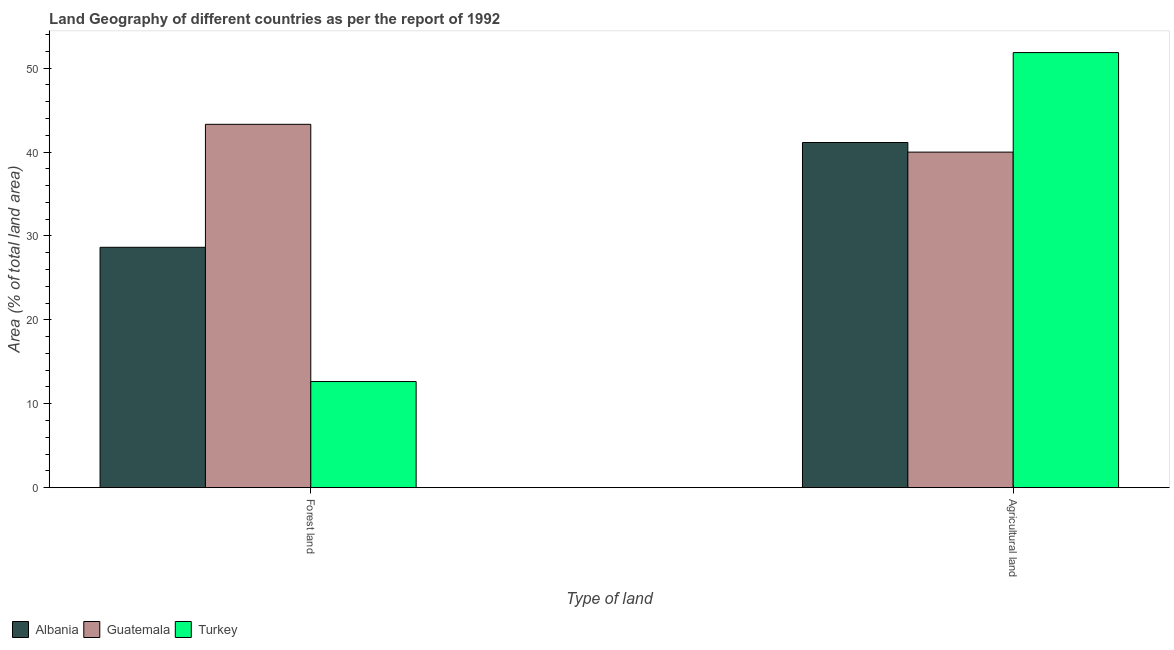Are the number of bars on each tick of the X-axis equal?
Provide a short and direct response. Yes. How many bars are there on the 1st tick from the right?
Offer a terse response. 3. What is the label of the 1st group of bars from the left?
Keep it short and to the point. Forest land. What is the percentage of land area under agriculture in Turkey?
Your response must be concise. 51.85. Across all countries, what is the maximum percentage of land area under forests?
Give a very brief answer. 43.3. Across all countries, what is the minimum percentage of land area under agriculture?
Offer a very short reply. 39.99. In which country was the percentage of land area under agriculture maximum?
Provide a succinct answer. Turkey. In which country was the percentage of land area under agriculture minimum?
Keep it short and to the point. Guatemala. What is the total percentage of land area under forests in the graph?
Your answer should be very brief. 84.59. What is the difference between the percentage of land area under agriculture in Turkey and that in Guatemala?
Your answer should be very brief. 11.86. What is the difference between the percentage of land area under forests in Albania and the percentage of land area under agriculture in Turkey?
Keep it short and to the point. -23.2. What is the average percentage of land area under agriculture per country?
Offer a very short reply. 44.32. What is the difference between the percentage of land area under forests and percentage of land area under agriculture in Turkey?
Provide a short and direct response. -39.2. In how many countries, is the percentage of land area under forests greater than 34 %?
Give a very brief answer. 1. What is the ratio of the percentage of land area under forests in Guatemala to that in Albania?
Ensure brevity in your answer.  1.51. Is the percentage of land area under agriculture in Albania less than that in Guatemala?
Make the answer very short. No. In how many countries, is the percentage of land area under agriculture greater than the average percentage of land area under agriculture taken over all countries?
Make the answer very short. 1. What does the 2nd bar from the left in Forest land represents?
Your answer should be very brief. Guatemala. What does the 1st bar from the right in Agricultural land represents?
Offer a terse response. Turkey. Are all the bars in the graph horizontal?
Keep it short and to the point. No. Does the graph contain grids?
Provide a short and direct response. No. How many legend labels are there?
Provide a succinct answer. 3. How are the legend labels stacked?
Your answer should be very brief. Horizontal. What is the title of the graph?
Provide a succinct answer. Land Geography of different countries as per the report of 1992. Does "Hungary" appear as one of the legend labels in the graph?
Keep it short and to the point. No. What is the label or title of the X-axis?
Give a very brief answer. Type of land. What is the label or title of the Y-axis?
Your answer should be compact. Area (% of total land area). What is the Area (% of total land area) of Albania in Forest land?
Offer a very short reply. 28.65. What is the Area (% of total land area) in Guatemala in Forest land?
Offer a very short reply. 43.3. What is the Area (% of total land area) of Turkey in Forest land?
Give a very brief answer. 12.65. What is the Area (% of total land area) of Albania in Agricultural land?
Make the answer very short. 41.13. What is the Area (% of total land area) of Guatemala in Agricultural land?
Ensure brevity in your answer.  39.99. What is the Area (% of total land area) of Turkey in Agricultural land?
Make the answer very short. 51.85. Across all Type of land, what is the maximum Area (% of total land area) in Albania?
Provide a succinct answer. 41.13. Across all Type of land, what is the maximum Area (% of total land area) of Guatemala?
Give a very brief answer. 43.3. Across all Type of land, what is the maximum Area (% of total land area) in Turkey?
Ensure brevity in your answer.  51.85. Across all Type of land, what is the minimum Area (% of total land area) of Albania?
Your answer should be compact. 28.65. Across all Type of land, what is the minimum Area (% of total land area) of Guatemala?
Your answer should be compact. 39.99. Across all Type of land, what is the minimum Area (% of total land area) of Turkey?
Provide a succinct answer. 12.65. What is the total Area (% of total land area) in Albania in the graph?
Provide a succinct answer. 69.78. What is the total Area (% of total land area) of Guatemala in the graph?
Provide a succinct answer. 83.29. What is the total Area (% of total land area) of Turkey in the graph?
Offer a very short reply. 64.5. What is the difference between the Area (% of total land area) in Albania in Forest land and that in Agricultural land?
Your answer should be compact. -12.49. What is the difference between the Area (% of total land area) in Guatemala in Forest land and that in Agricultural land?
Offer a terse response. 3.31. What is the difference between the Area (% of total land area) of Turkey in Forest land and that in Agricultural land?
Give a very brief answer. -39.2. What is the difference between the Area (% of total land area) in Albania in Forest land and the Area (% of total land area) in Guatemala in Agricultural land?
Provide a short and direct response. -11.34. What is the difference between the Area (% of total land area) in Albania in Forest land and the Area (% of total land area) in Turkey in Agricultural land?
Provide a short and direct response. -23.2. What is the difference between the Area (% of total land area) of Guatemala in Forest land and the Area (% of total land area) of Turkey in Agricultural land?
Provide a succinct answer. -8.55. What is the average Area (% of total land area) in Albania per Type of land?
Your answer should be compact. 34.89. What is the average Area (% of total land area) of Guatemala per Type of land?
Offer a very short reply. 41.64. What is the average Area (% of total land area) of Turkey per Type of land?
Your answer should be compact. 32.25. What is the difference between the Area (% of total land area) of Albania and Area (% of total land area) of Guatemala in Forest land?
Your response must be concise. -14.65. What is the difference between the Area (% of total land area) of Albania and Area (% of total land area) of Turkey in Forest land?
Offer a very short reply. 16. What is the difference between the Area (% of total land area) of Guatemala and Area (% of total land area) of Turkey in Forest land?
Give a very brief answer. 30.65. What is the difference between the Area (% of total land area) in Albania and Area (% of total land area) in Guatemala in Agricultural land?
Your answer should be compact. 1.14. What is the difference between the Area (% of total land area) of Albania and Area (% of total land area) of Turkey in Agricultural land?
Your response must be concise. -10.72. What is the difference between the Area (% of total land area) of Guatemala and Area (% of total land area) of Turkey in Agricultural land?
Offer a terse response. -11.86. What is the ratio of the Area (% of total land area) of Albania in Forest land to that in Agricultural land?
Offer a terse response. 0.7. What is the ratio of the Area (% of total land area) in Guatemala in Forest land to that in Agricultural land?
Give a very brief answer. 1.08. What is the ratio of the Area (% of total land area) in Turkey in Forest land to that in Agricultural land?
Provide a succinct answer. 0.24. What is the difference between the highest and the second highest Area (% of total land area) in Albania?
Provide a succinct answer. 12.49. What is the difference between the highest and the second highest Area (% of total land area) in Guatemala?
Give a very brief answer. 3.31. What is the difference between the highest and the second highest Area (% of total land area) of Turkey?
Ensure brevity in your answer.  39.2. What is the difference between the highest and the lowest Area (% of total land area) in Albania?
Give a very brief answer. 12.49. What is the difference between the highest and the lowest Area (% of total land area) of Guatemala?
Offer a terse response. 3.31. What is the difference between the highest and the lowest Area (% of total land area) of Turkey?
Give a very brief answer. 39.2. 